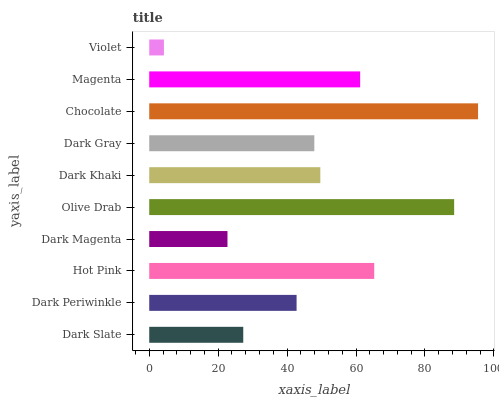Is Violet the minimum?
Answer yes or no. Yes. Is Chocolate the maximum?
Answer yes or no. Yes. Is Dark Periwinkle the minimum?
Answer yes or no. No. Is Dark Periwinkle the maximum?
Answer yes or no. No. Is Dark Periwinkle greater than Dark Slate?
Answer yes or no. Yes. Is Dark Slate less than Dark Periwinkle?
Answer yes or no. Yes. Is Dark Slate greater than Dark Periwinkle?
Answer yes or no. No. Is Dark Periwinkle less than Dark Slate?
Answer yes or no. No. Is Dark Khaki the high median?
Answer yes or no. Yes. Is Dark Gray the low median?
Answer yes or no. Yes. Is Dark Gray the high median?
Answer yes or no. No. Is Dark Periwinkle the low median?
Answer yes or no. No. 